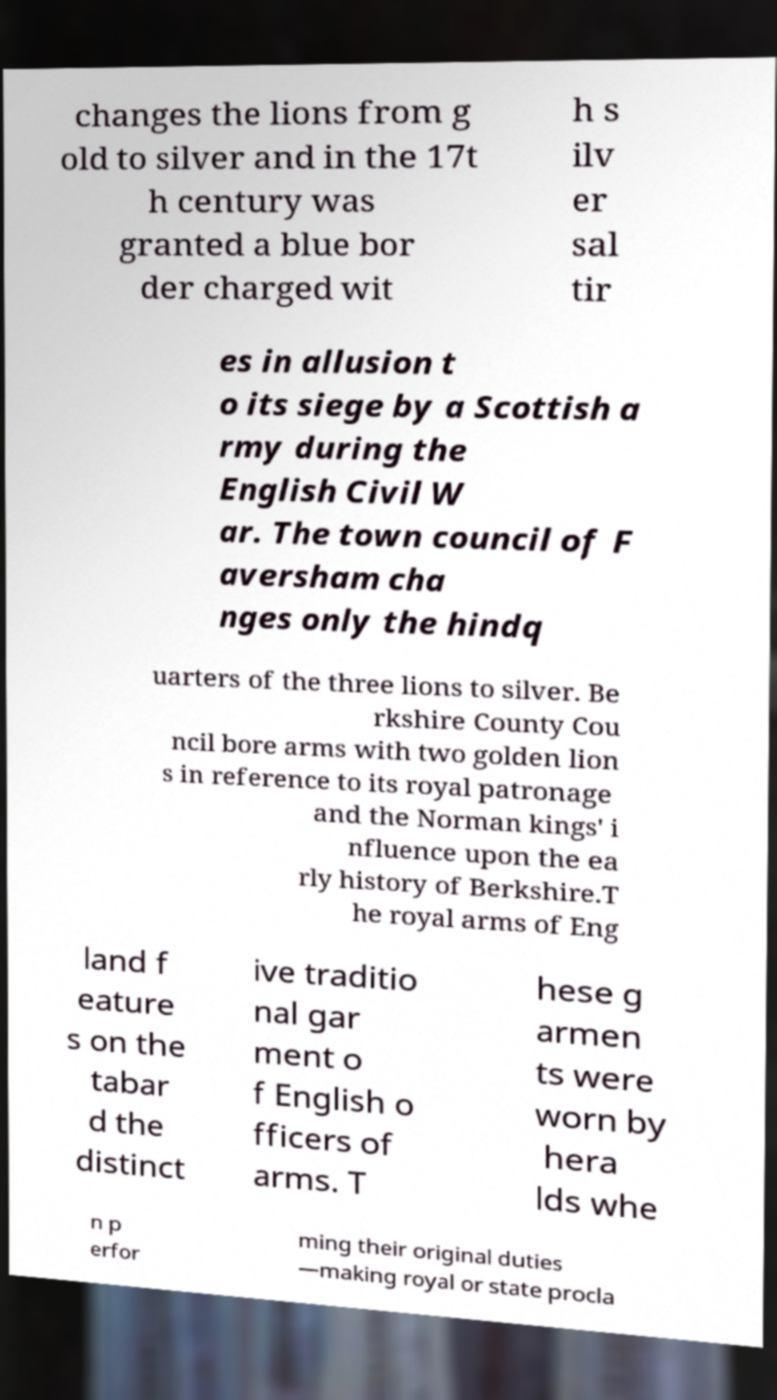Could you assist in decoding the text presented in this image and type it out clearly? changes the lions from g old to silver and in the 17t h century was granted a blue bor der charged wit h s ilv er sal tir es in allusion t o its siege by a Scottish a rmy during the English Civil W ar. The town council of F aversham cha nges only the hindq uarters of the three lions to silver. Be rkshire County Cou ncil bore arms with two golden lion s in reference to its royal patronage and the Norman kings' i nfluence upon the ea rly history of Berkshire.T he royal arms of Eng land f eature s on the tabar d the distinct ive traditio nal gar ment o f English o fficers of arms. T hese g armen ts were worn by hera lds whe n p erfor ming their original duties —making royal or state procla 